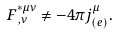<formula> <loc_0><loc_0><loc_500><loc_500>F ^ { * \mu \nu } _ { \, , \nu } \neq - 4 \pi j ^ { \mu } _ { ( e ) } .</formula> 